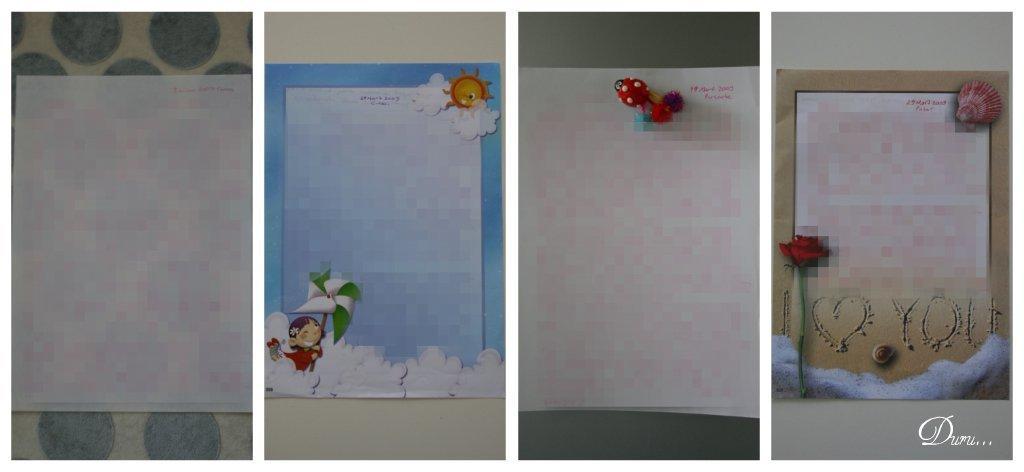Can you describe this image briefly? This image consists of four greeting cards which are edited and made as a collage. 